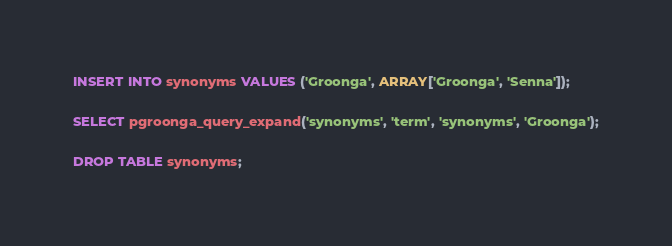<code> <loc_0><loc_0><loc_500><loc_500><_SQL_>
INSERT INTO synonyms VALUES ('Groonga', ARRAY['Groonga', 'Senna']);

SELECT pgroonga_query_expand('synonyms', 'term', 'synonyms', 'Groonga');

DROP TABLE synonyms;
</code> 